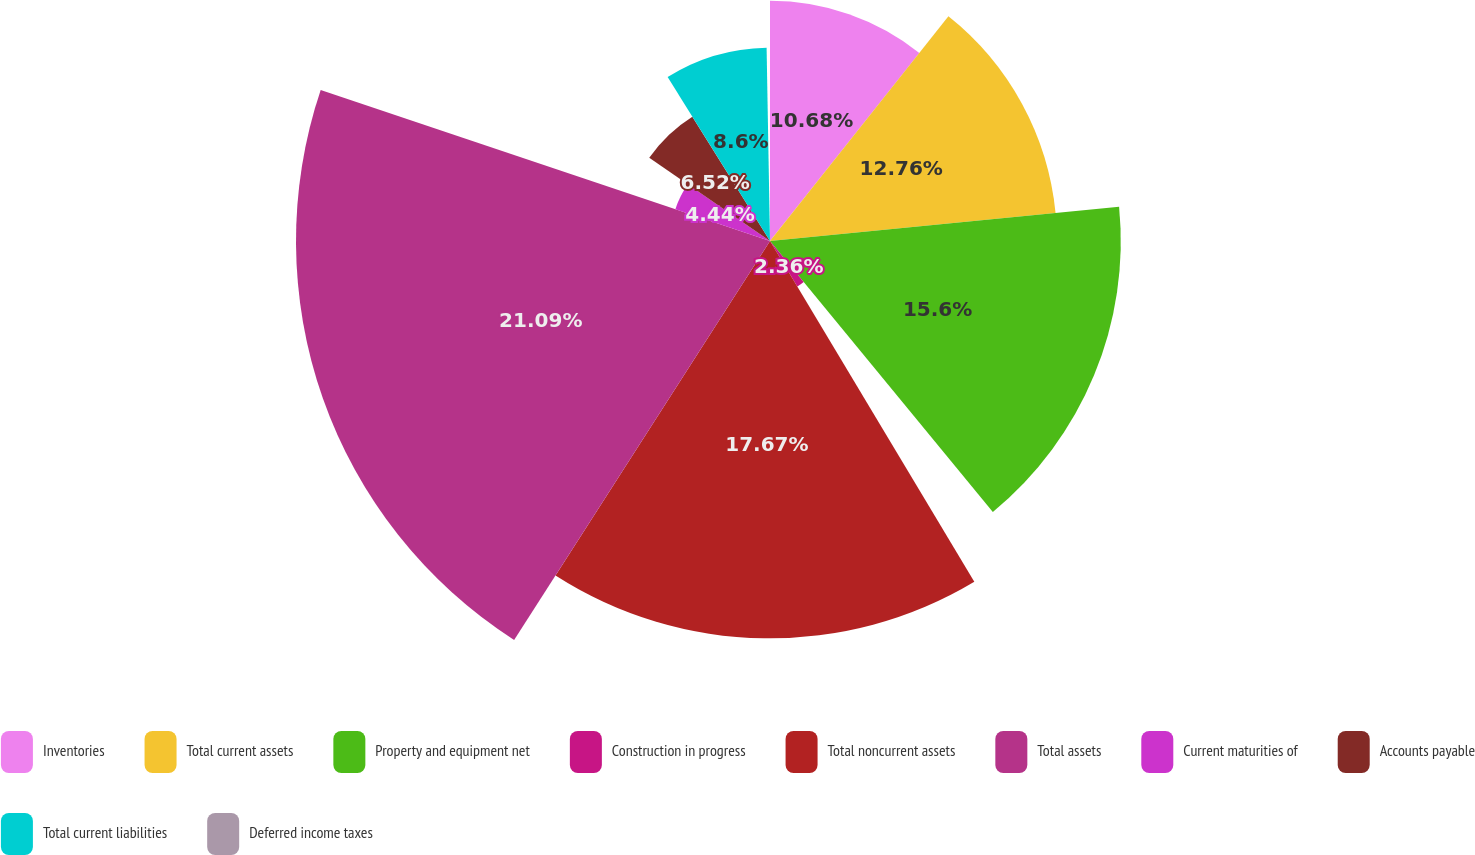<chart> <loc_0><loc_0><loc_500><loc_500><pie_chart><fcel>Inventories<fcel>Total current assets<fcel>Property and equipment net<fcel>Construction in progress<fcel>Total noncurrent assets<fcel>Total assets<fcel>Current maturities of<fcel>Accounts payable<fcel>Total current liabilities<fcel>Deferred income taxes<nl><fcel>10.68%<fcel>12.76%<fcel>15.6%<fcel>2.36%<fcel>17.67%<fcel>21.08%<fcel>4.44%<fcel>6.52%<fcel>8.6%<fcel>0.28%<nl></chart> 